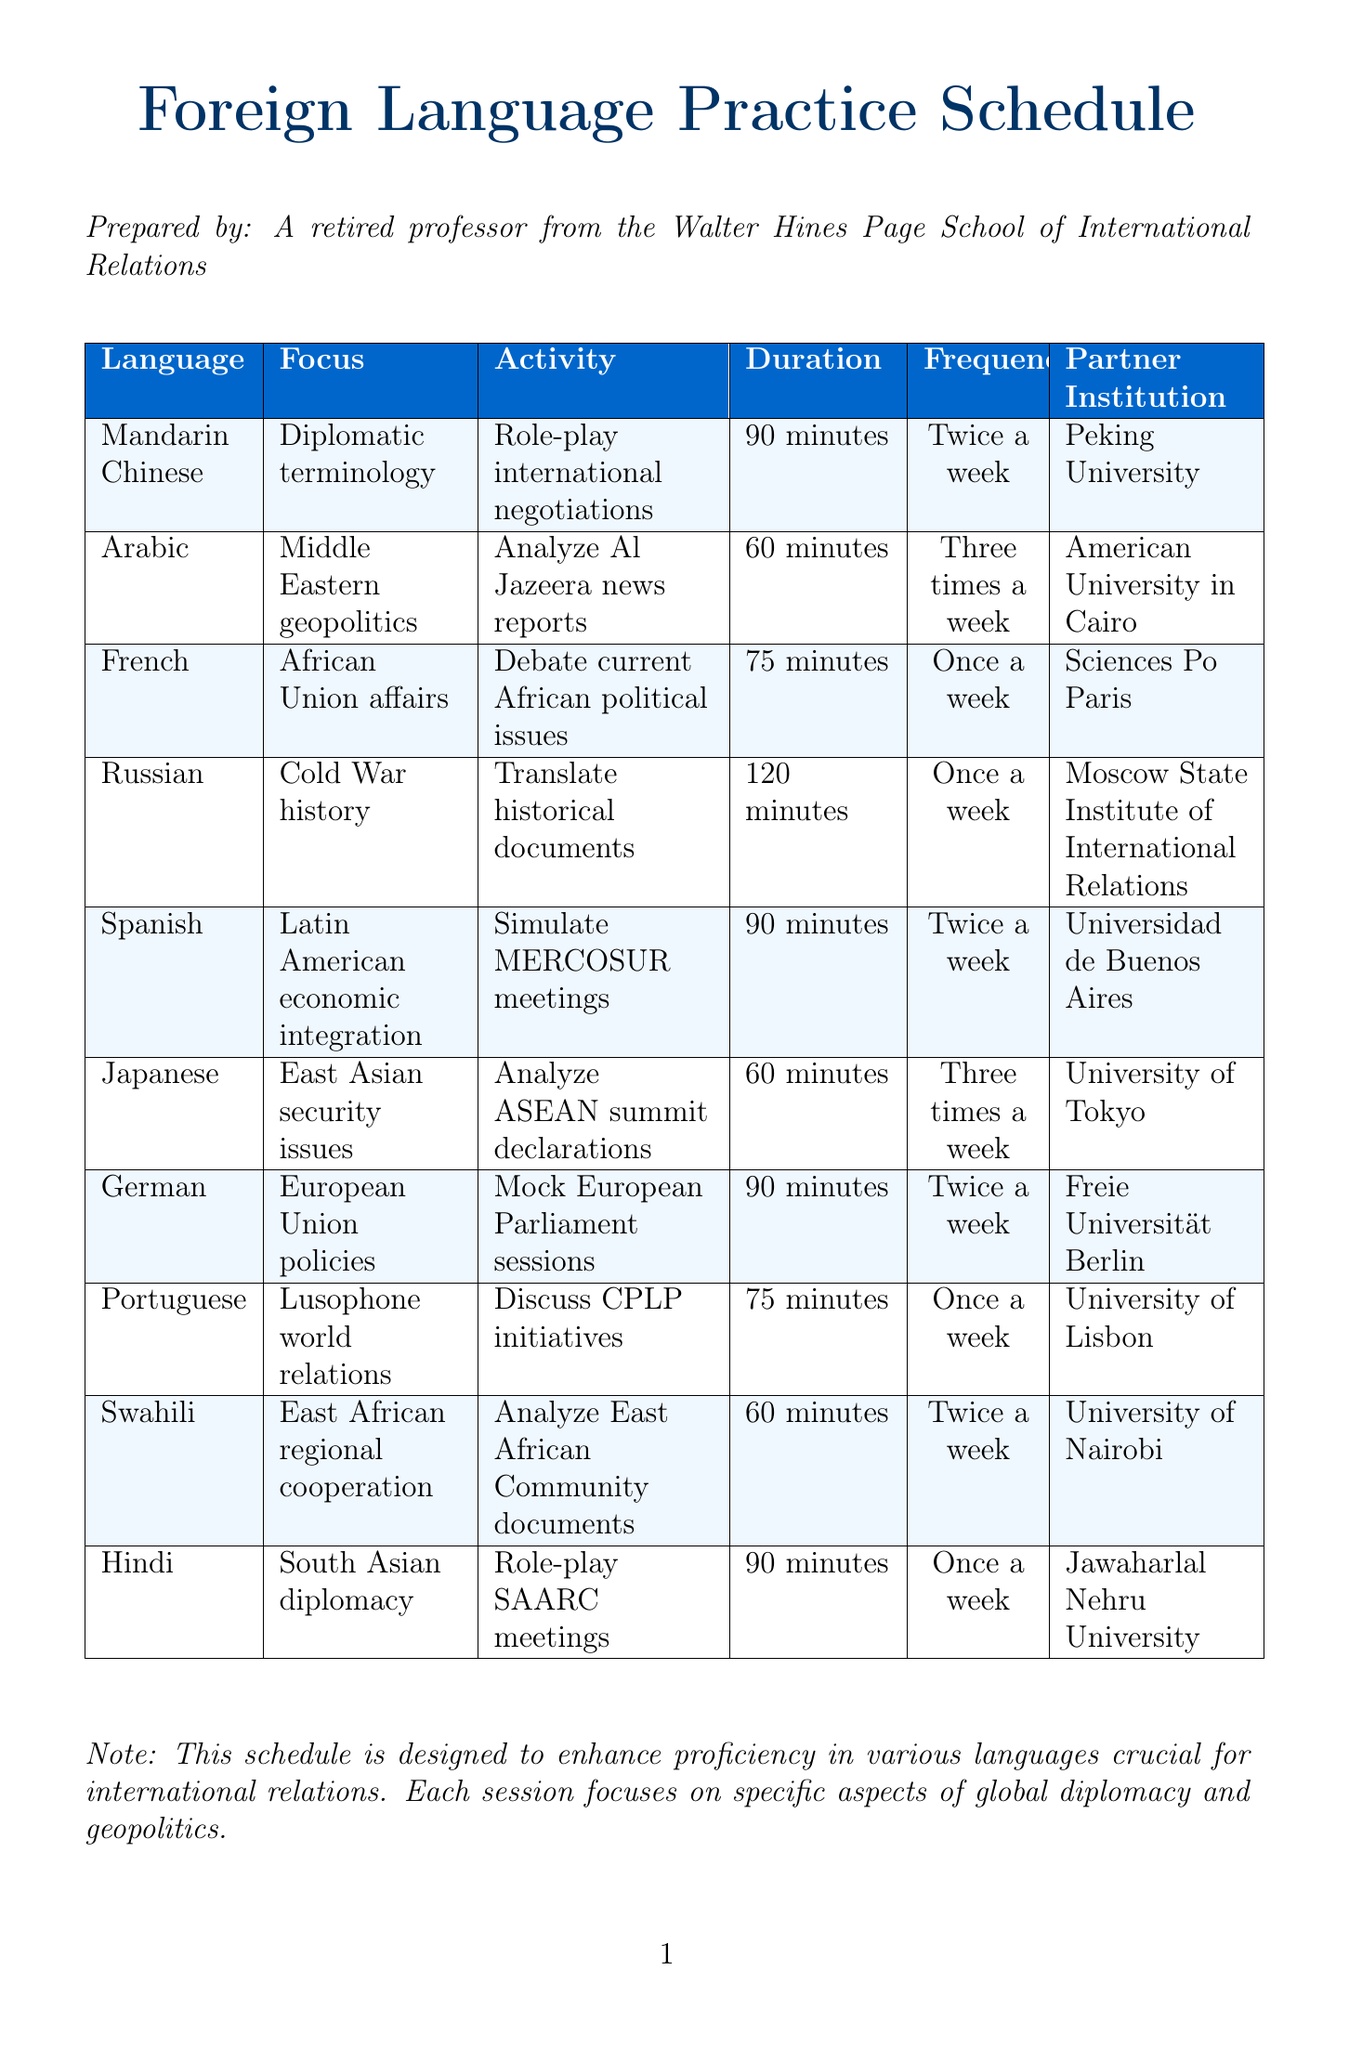What is the frequency of Mandarin Chinese sessions? The frequency is stated as "Twice a week" in the document.
Answer: Twice a week How long is each Arabic session? The document specifies the duration of each Arabic session as "60 minutes".
Answer: 60 minutes What institution partners with the Spanish language practice? According to the document, the partner institution for Spanish is "Universidad de Buenos Aires".
Answer: Universidad de Buenos Aires Which languages have a focus on geopolitics? The document lists Arabic and Japanese as languages focusing on "Middle Eastern geopolitics" and "East Asian security issues", respectively.
Answer: Arabic, Japanese What is the total duration of the Russian sessions? The document indicates that Russian sessions have a duration of "120 minutes".
Answer: 120 minutes How many times a week are German sessions held? The document indicates that German sessions are held "Twice a week".
Answer: Twice a week Which language is paired with Peking University? The document specifies Mandarin Chinese as the language partnered with "Peking University".
Answer: Peking University What activity is associated with the Portuguese sessions? The document states that the activity for Portuguese sessions is to "Discuss CPLP initiatives".
Answer: Discuss CPLP initiatives How many languages are practiced at least three times a week? The document lists Arabic and Japanese, which are practiced three times a week, totaling two languages.
Answer: Two languages 